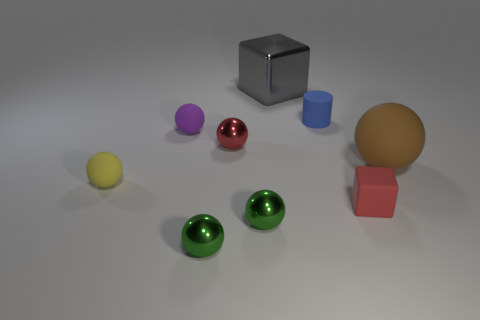Subtract all large brown balls. How many balls are left? 5 Subtract all red spheres. How many spheres are left? 5 Subtract 1 balls. How many balls are left? 5 Subtract all cyan spheres. How many red cubes are left? 1 Subtract all red cylinders. Subtract all gray balls. How many cylinders are left? 1 Subtract all small red metal objects. Subtract all tiny red matte objects. How many objects are left? 7 Add 4 small green balls. How many small green balls are left? 6 Add 3 gray cubes. How many gray cubes exist? 4 Add 1 shiny blocks. How many objects exist? 10 Subtract 1 yellow spheres. How many objects are left? 8 